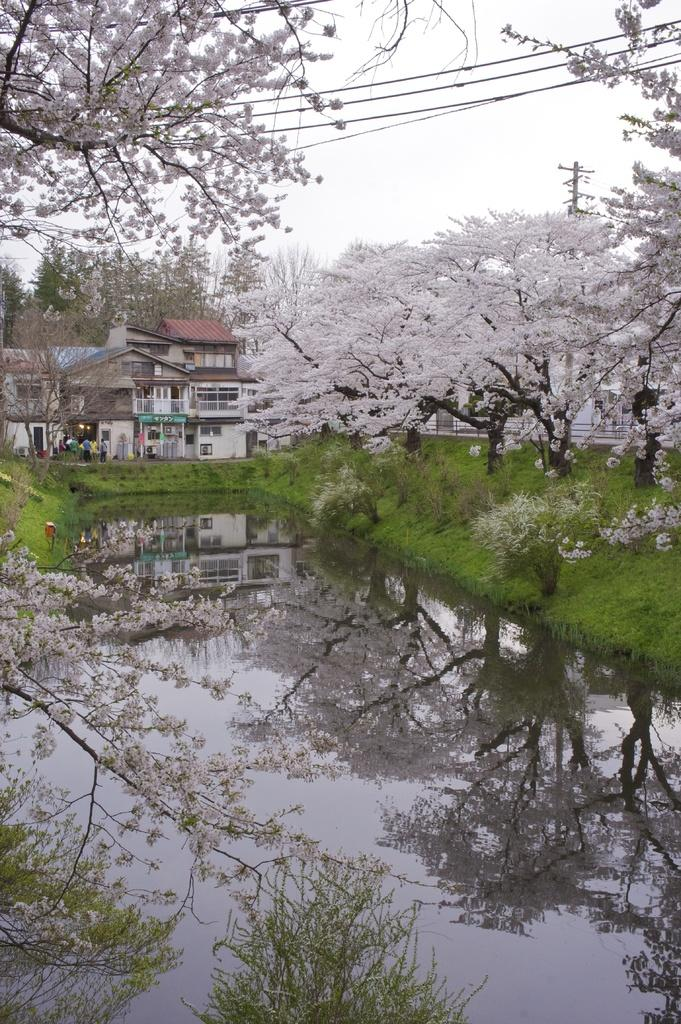What type of natural body of water is visible in the image? There is a lake in the image. What type of man-made structure can be seen in the image? There is a building in the image. What type of vegetation is present in the image? There are trees and plants in the image. What type of twig is being used as a serving tray for the plants in the image? There is no twig or tray present in the image; the plants are simply growing in the natural environment. What is the mouth of the lake doing in the image? The mouth of the lake is not a feature that can be observed in the image, as lakes do not have mouths. 